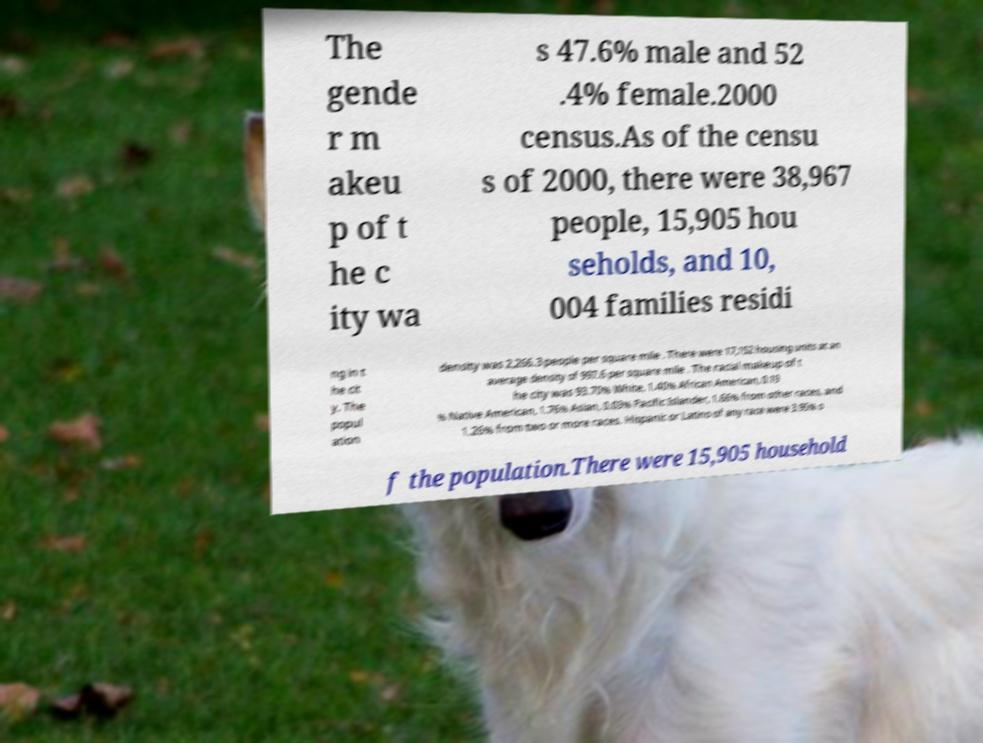For documentation purposes, I need the text within this image transcribed. Could you provide that? The gende r m akeu p of t he c ity wa s 47.6% male and 52 .4% female.2000 census.As of the censu s of 2000, there were 38,967 people, 15,905 hou seholds, and 10, 004 families residi ng in t he cit y. The popul ation density was 2,266.3 people per square mile . There were 17,152 housing units at an average density of 997.6 per square mile . The racial makeup of t he city was 93.70% White, 1.40% African American, 0.19 % Native American, 1.76% Asian, 0.03% Pacific Islander, 1.66% from other races, and 1.26% from two or more races. Hispanic or Latino of any race were 3.95% o f the population.There were 15,905 household 